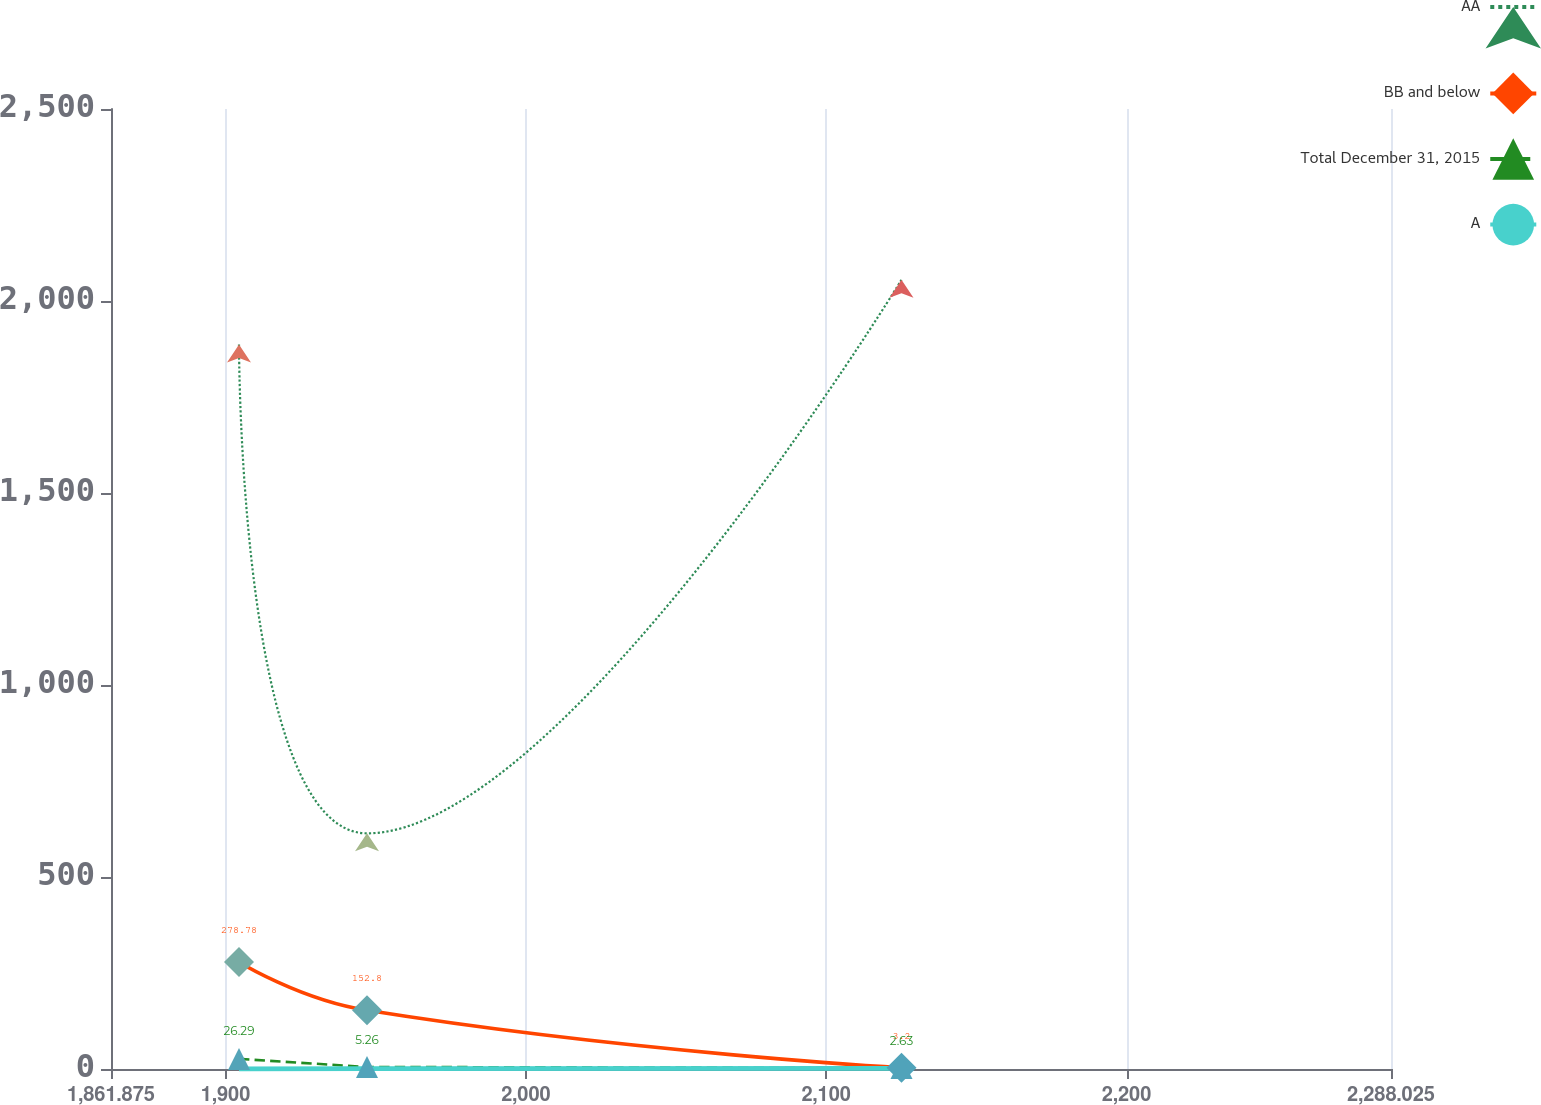Convert chart to OTSL. <chart><loc_0><loc_0><loc_500><loc_500><line_chart><ecel><fcel>AA<fcel>BB and below<fcel>Total December 31, 2015<fcel>A<nl><fcel>1904.49<fcel>1886.76<fcel>278.78<fcel>26.29<fcel>0<nl><fcel>1947.11<fcel>613.71<fcel>152.8<fcel>5.26<fcel>0.88<nl><fcel>2125.05<fcel>2055.02<fcel>3.2<fcel>2.63<fcel>1.76<nl><fcel>2330.64<fcel>2211.26<fcel>114.56<fcel>0<fcel>8.83<nl></chart> 